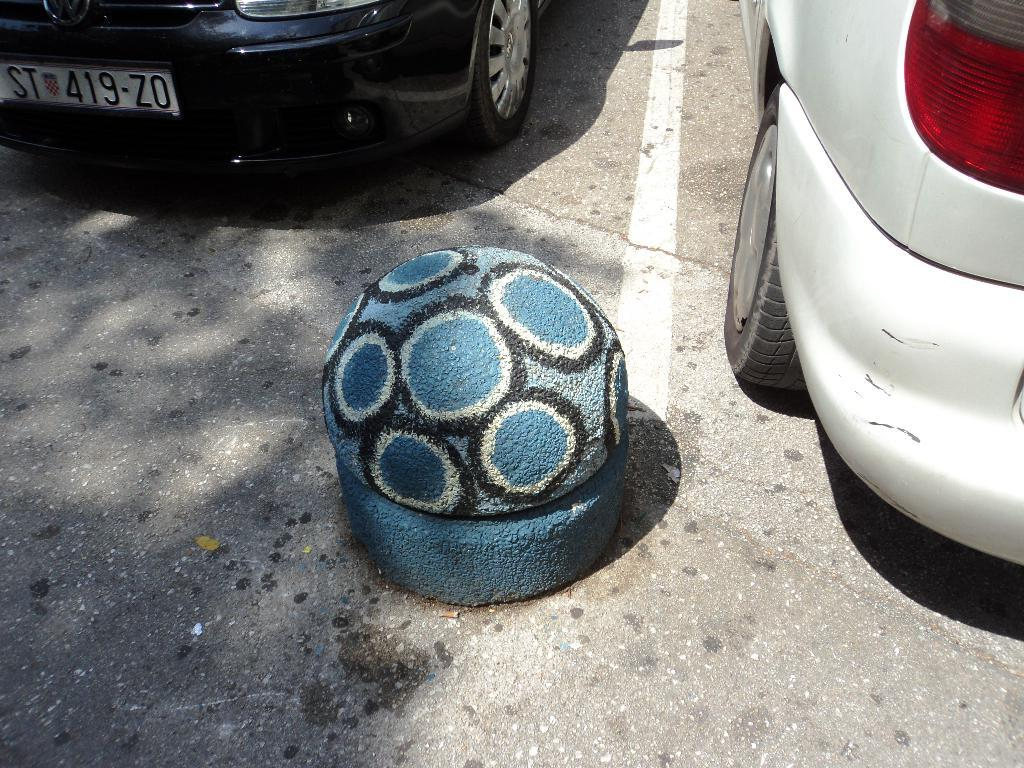How many vehicles can be seen in the image? There are two vehicles in the image. What is located on the platform in the image? There is a constructed ball on a platform in the image. Where is the platform situated? The platform is on a road. What type of stone is being used to draw on the road in the image? There is no stone or drawing on the road in the image; it only features two vehicles, a platform, and a constructed ball. 